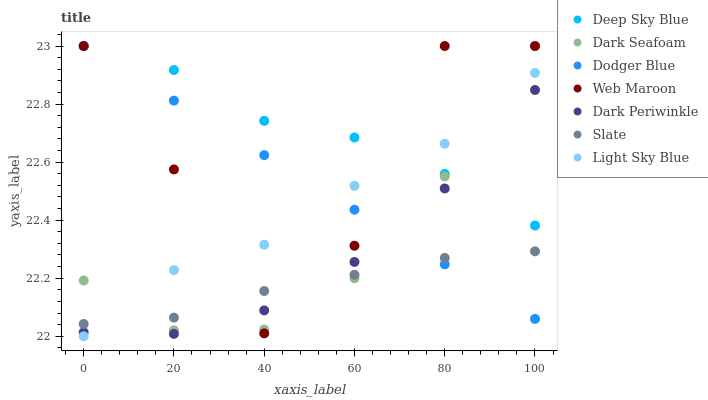Does Slate have the minimum area under the curve?
Answer yes or no. Yes. Does Deep Sky Blue have the maximum area under the curve?
Answer yes or no. Yes. Does Web Maroon have the minimum area under the curve?
Answer yes or no. No. Does Web Maroon have the maximum area under the curve?
Answer yes or no. No. Is Dodger Blue the smoothest?
Answer yes or no. Yes. Is Web Maroon the roughest?
Answer yes or no. Yes. Is Dark Seafoam the smoothest?
Answer yes or no. No. Is Dark Seafoam the roughest?
Answer yes or no. No. Does Light Sky Blue have the lowest value?
Answer yes or no. Yes. Does Web Maroon have the lowest value?
Answer yes or no. No. Does Deep Sky Blue have the highest value?
Answer yes or no. Yes. Does Light Sky Blue have the highest value?
Answer yes or no. No. Is Slate less than Deep Sky Blue?
Answer yes or no. Yes. Is Deep Sky Blue greater than Slate?
Answer yes or no. Yes. Does Web Maroon intersect Dodger Blue?
Answer yes or no. Yes. Is Web Maroon less than Dodger Blue?
Answer yes or no. No. Is Web Maroon greater than Dodger Blue?
Answer yes or no. No. Does Slate intersect Deep Sky Blue?
Answer yes or no. No. 